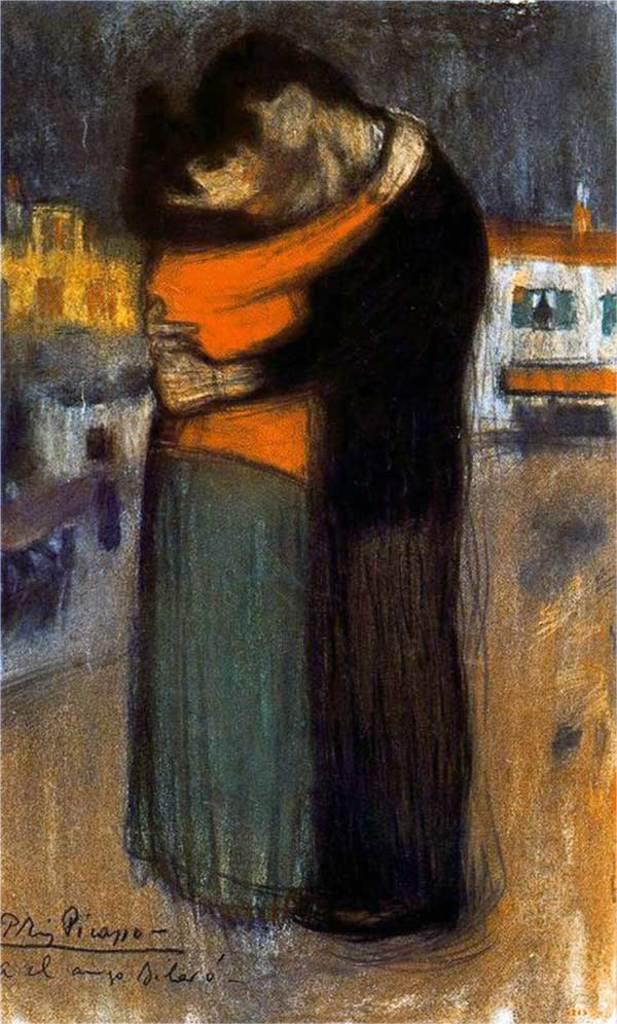What is the main subject of the painting in the image? The painting depicts two people hugging each other. What can be seen in the background of the painting? There are houses visible in the background of the painting. Where is the text located in the image? The text is in the bottom left corner of the image. Can you describe the detail of the toe in the painting? There is no toe visible in the painting; it depicts two people hugging each other with no visible body parts other than their upper bodies and heads. 